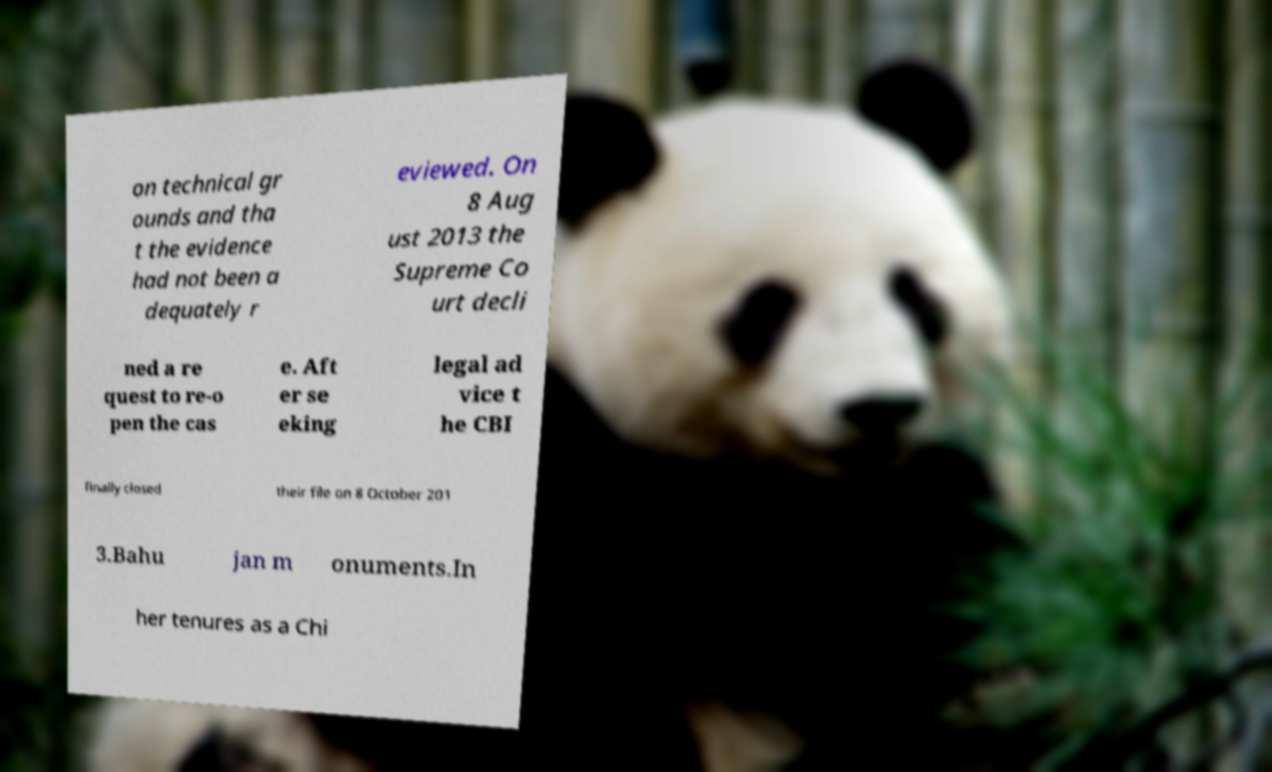For documentation purposes, I need the text within this image transcribed. Could you provide that? on technical gr ounds and tha t the evidence had not been a dequately r eviewed. On 8 Aug ust 2013 the Supreme Co urt decli ned a re quest to re-o pen the cas e. Aft er se eking legal ad vice t he CBI finally closed their file on 8 October 201 3.Bahu jan m onuments.In her tenures as a Chi 